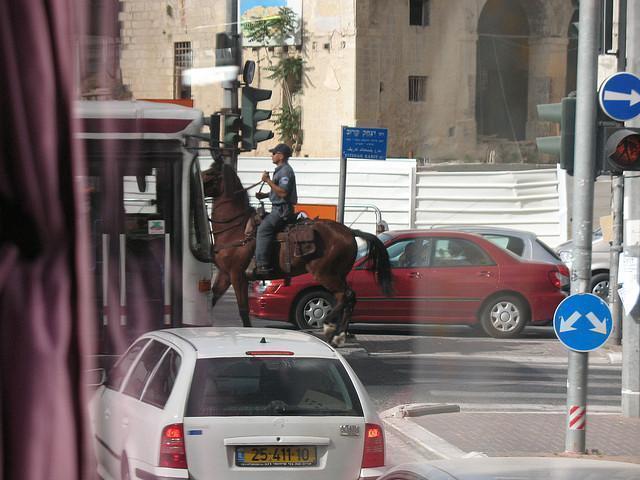What model is the red car?
Choose the correct response, then elucidate: 'Answer: answer
Rationale: rationale.'
Options: Hatchback, sedan, station wagon, coupe. Answer: sedan.
Rationale: The model of the car is a sedan. 